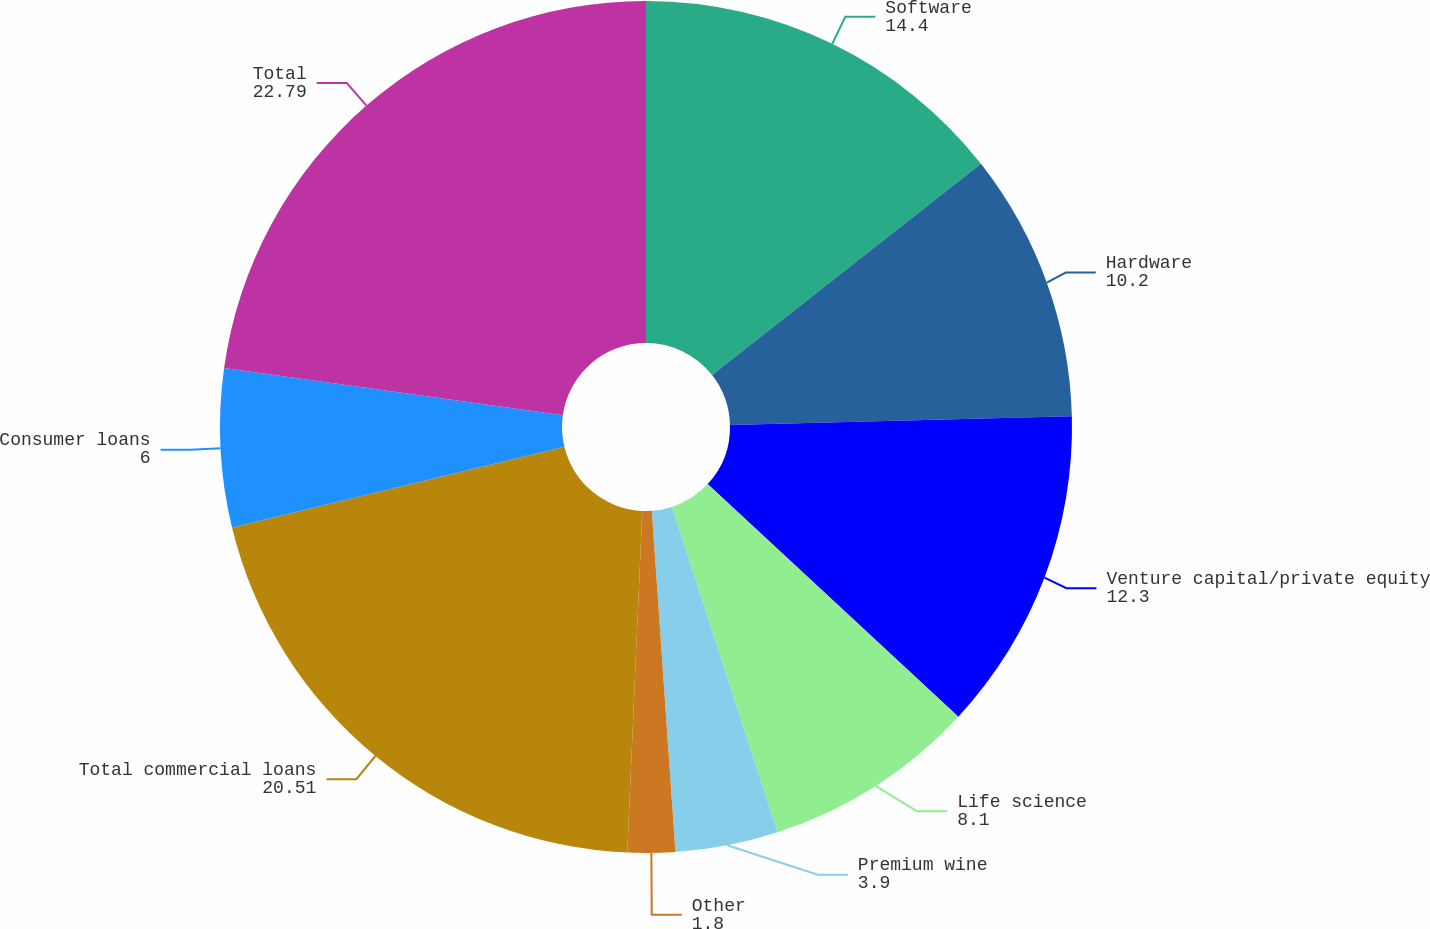<chart> <loc_0><loc_0><loc_500><loc_500><pie_chart><fcel>Software<fcel>Hardware<fcel>Venture capital/private equity<fcel>Life science<fcel>Premium wine<fcel>Other<fcel>Total commercial loans<fcel>Consumer loans<fcel>Total<nl><fcel>14.4%<fcel>10.2%<fcel>12.3%<fcel>8.1%<fcel>3.9%<fcel>1.8%<fcel>20.51%<fcel>6.0%<fcel>22.79%<nl></chart> 